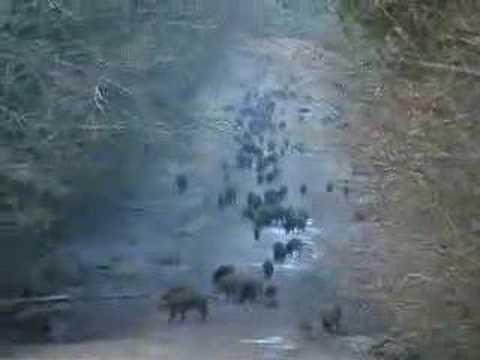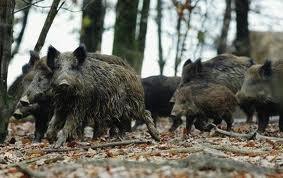The first image is the image on the left, the second image is the image on the right. Analyze the images presented: Is the assertion "One image shows a group of hogs on a bright green field." valid? Answer yes or no. No. The first image is the image on the left, the second image is the image on the right. Evaluate the accuracy of this statement regarding the images: "The animals in one of the images are moving directly toward the camera.". Is it true? Answer yes or no. No. 